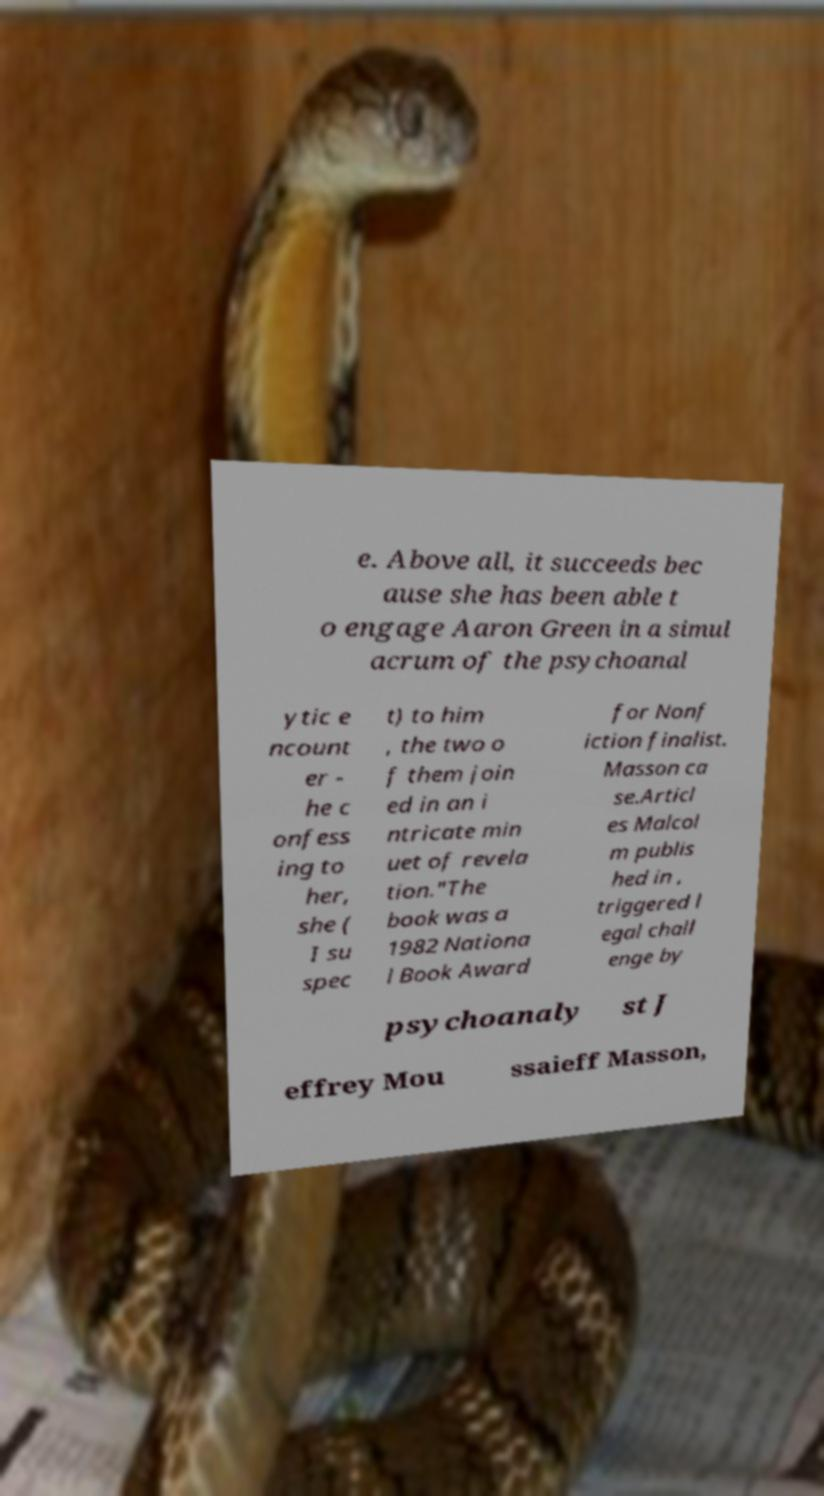Could you extract and type out the text from this image? e. Above all, it succeeds bec ause she has been able t o engage Aaron Green in a simul acrum of the psychoanal ytic e ncount er - he c onfess ing to her, she ( I su spec t) to him , the two o f them join ed in an i ntricate min uet of revela tion."The book was a 1982 Nationa l Book Award for Nonf iction finalist. Masson ca se.Articl es Malcol m publis hed in , triggered l egal chall enge by psychoanaly st J effrey Mou ssaieff Masson, 